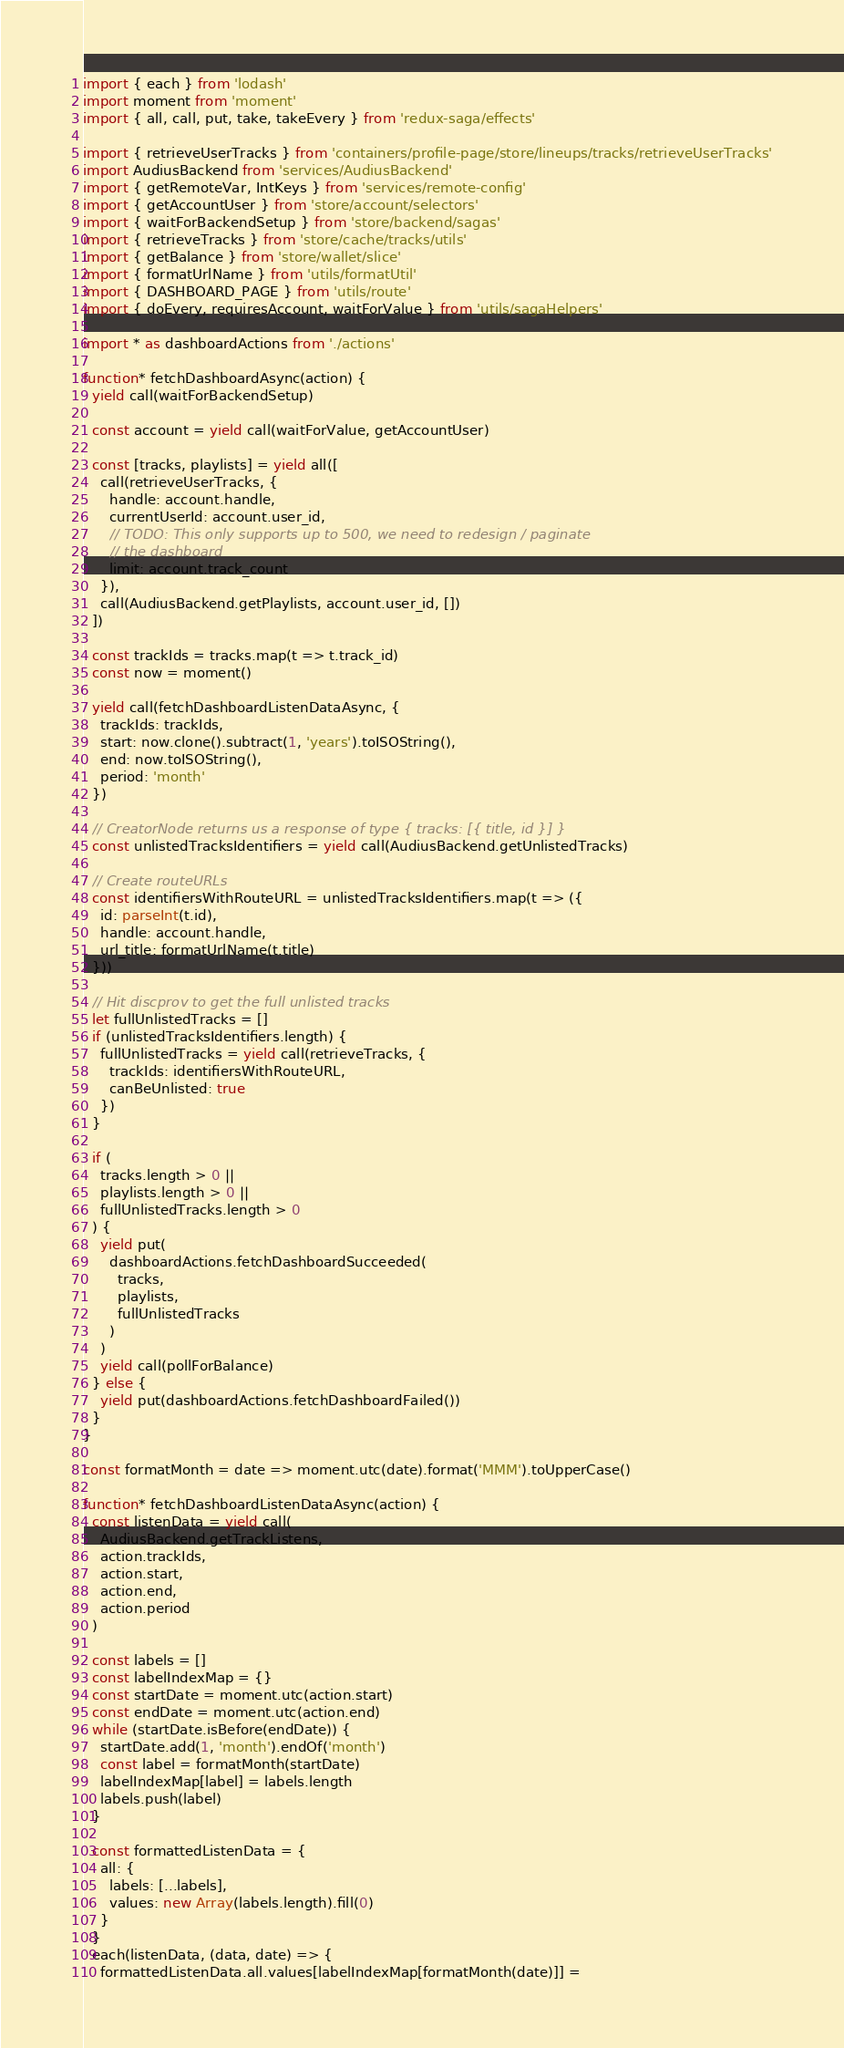Convert code to text. <code><loc_0><loc_0><loc_500><loc_500><_JavaScript_>import { each } from 'lodash'
import moment from 'moment'
import { all, call, put, take, takeEvery } from 'redux-saga/effects'

import { retrieveUserTracks } from 'containers/profile-page/store/lineups/tracks/retrieveUserTracks'
import AudiusBackend from 'services/AudiusBackend'
import { getRemoteVar, IntKeys } from 'services/remote-config'
import { getAccountUser } from 'store/account/selectors'
import { waitForBackendSetup } from 'store/backend/sagas'
import { retrieveTracks } from 'store/cache/tracks/utils'
import { getBalance } from 'store/wallet/slice'
import { formatUrlName } from 'utils/formatUtil'
import { DASHBOARD_PAGE } from 'utils/route'
import { doEvery, requiresAccount, waitForValue } from 'utils/sagaHelpers'

import * as dashboardActions from './actions'

function* fetchDashboardAsync(action) {
  yield call(waitForBackendSetup)

  const account = yield call(waitForValue, getAccountUser)

  const [tracks, playlists] = yield all([
    call(retrieveUserTracks, {
      handle: account.handle,
      currentUserId: account.user_id,
      // TODO: This only supports up to 500, we need to redesign / paginate
      // the dashboard
      limit: account.track_count
    }),
    call(AudiusBackend.getPlaylists, account.user_id, [])
  ])

  const trackIds = tracks.map(t => t.track_id)
  const now = moment()

  yield call(fetchDashboardListenDataAsync, {
    trackIds: trackIds,
    start: now.clone().subtract(1, 'years').toISOString(),
    end: now.toISOString(),
    period: 'month'
  })

  // CreatorNode returns us a response of type { tracks: [{ title, id }] }
  const unlistedTracksIdentifiers = yield call(AudiusBackend.getUnlistedTracks)

  // Create routeURLs
  const identifiersWithRouteURL = unlistedTracksIdentifiers.map(t => ({
    id: parseInt(t.id),
    handle: account.handle,
    url_title: formatUrlName(t.title)
  }))

  // Hit discprov to get the full unlisted tracks
  let fullUnlistedTracks = []
  if (unlistedTracksIdentifiers.length) {
    fullUnlistedTracks = yield call(retrieveTracks, {
      trackIds: identifiersWithRouteURL,
      canBeUnlisted: true
    })
  }

  if (
    tracks.length > 0 ||
    playlists.length > 0 ||
    fullUnlistedTracks.length > 0
  ) {
    yield put(
      dashboardActions.fetchDashboardSucceeded(
        tracks,
        playlists,
        fullUnlistedTracks
      )
    )
    yield call(pollForBalance)
  } else {
    yield put(dashboardActions.fetchDashboardFailed())
  }
}

const formatMonth = date => moment.utc(date).format('MMM').toUpperCase()

function* fetchDashboardListenDataAsync(action) {
  const listenData = yield call(
    AudiusBackend.getTrackListens,
    action.trackIds,
    action.start,
    action.end,
    action.period
  )

  const labels = []
  const labelIndexMap = {}
  const startDate = moment.utc(action.start)
  const endDate = moment.utc(action.end)
  while (startDate.isBefore(endDate)) {
    startDate.add(1, 'month').endOf('month')
    const label = formatMonth(startDate)
    labelIndexMap[label] = labels.length
    labels.push(label)
  }

  const formattedListenData = {
    all: {
      labels: [...labels],
      values: new Array(labels.length).fill(0)
    }
  }
  each(listenData, (data, date) => {
    formattedListenData.all.values[labelIndexMap[formatMonth(date)]] =</code> 